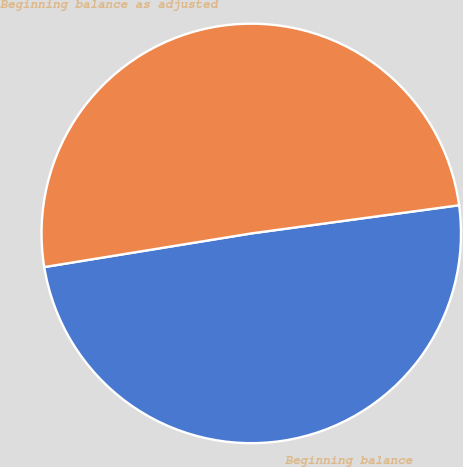Convert chart to OTSL. <chart><loc_0><loc_0><loc_500><loc_500><pie_chart><fcel>Beginning balance<fcel>Beginning balance as adjusted<nl><fcel>49.58%<fcel>50.42%<nl></chart> 